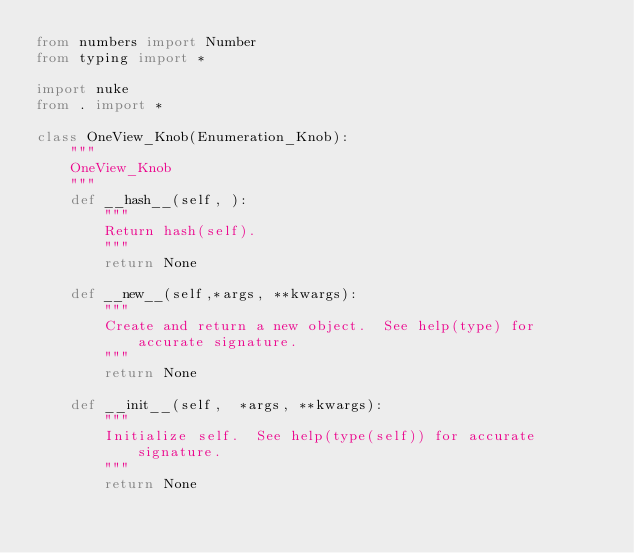Convert code to text. <code><loc_0><loc_0><loc_500><loc_500><_Python_>from numbers import Number
from typing import *

import nuke
from . import *

class OneView_Knob(Enumeration_Knob):
    """
    OneView_Knob
    """
    def __hash__(self, ):
        """
        Return hash(self).
        """
        return None

    def __new__(self,*args, **kwargs):
        """
        Create and return a new object.  See help(type) for accurate signature.
        """
        return None

    def __init__(self,  *args, **kwargs):
        """
        Initialize self.  See help(type(self)) for accurate signature.
        """
        return None</code> 